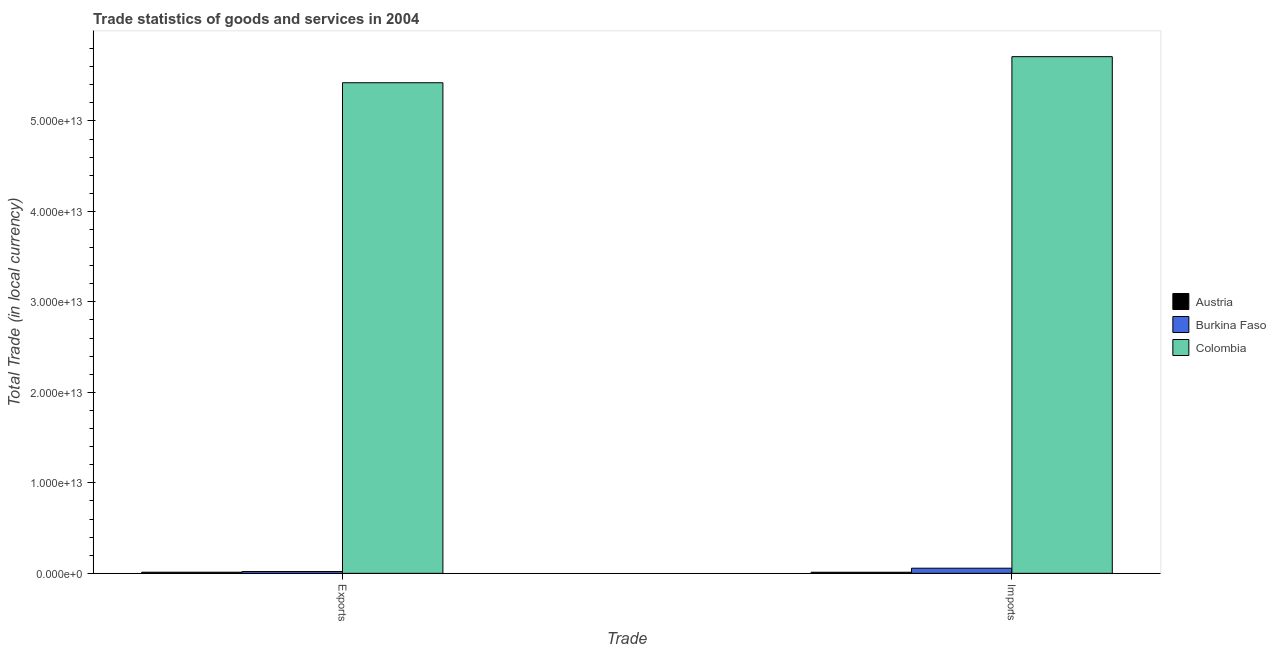How many bars are there on the 2nd tick from the left?
Offer a very short reply. 3. How many bars are there on the 2nd tick from the right?
Offer a terse response. 3. What is the label of the 2nd group of bars from the left?
Your answer should be compact. Imports. What is the export of goods and services in Austria?
Your answer should be compact. 1.24e+11. Across all countries, what is the maximum imports of goods and services?
Your response must be concise. 5.71e+13. Across all countries, what is the minimum imports of goods and services?
Keep it short and to the point. 1.20e+11. In which country was the export of goods and services maximum?
Offer a very short reply. Colombia. In which country was the imports of goods and services minimum?
Keep it short and to the point. Austria. What is the total export of goods and services in the graph?
Your answer should be compact. 5.45e+13. What is the difference between the export of goods and services in Burkina Faso and that in Austria?
Give a very brief answer. 7.61e+1. What is the difference between the export of goods and services in Burkina Faso and the imports of goods and services in Austria?
Offer a terse response. 7.99e+1. What is the average export of goods and services per country?
Provide a succinct answer. 1.82e+13. What is the difference between the export of goods and services and imports of goods and services in Colombia?
Keep it short and to the point. -2.88e+12. What is the ratio of the export of goods and services in Burkina Faso to that in Austria?
Offer a terse response. 1.62. Is the imports of goods and services in Austria less than that in Colombia?
Provide a succinct answer. Yes. In how many countries, is the imports of goods and services greater than the average imports of goods and services taken over all countries?
Your answer should be compact. 1. What does the 2nd bar from the left in Exports represents?
Make the answer very short. Burkina Faso. How many bars are there?
Provide a succinct answer. 6. What is the difference between two consecutive major ticks on the Y-axis?
Provide a succinct answer. 1.00e+13. Are the values on the major ticks of Y-axis written in scientific E-notation?
Provide a short and direct response. Yes. Does the graph contain grids?
Your answer should be compact. No. How are the legend labels stacked?
Your answer should be very brief. Vertical. What is the title of the graph?
Provide a succinct answer. Trade statistics of goods and services in 2004. Does "Fragile and conflict affected situations" appear as one of the legend labels in the graph?
Make the answer very short. No. What is the label or title of the X-axis?
Your answer should be very brief. Trade. What is the label or title of the Y-axis?
Offer a terse response. Total Trade (in local currency). What is the Total Trade (in local currency) in Austria in Exports?
Give a very brief answer. 1.24e+11. What is the Total Trade (in local currency) of Burkina Faso in Exports?
Make the answer very short. 2.00e+11. What is the Total Trade (in local currency) in Colombia in Exports?
Offer a very short reply. 5.42e+13. What is the Total Trade (in local currency) of Austria in Imports?
Keep it short and to the point. 1.20e+11. What is the Total Trade (in local currency) of Burkina Faso in Imports?
Offer a terse response. 5.67e+11. What is the Total Trade (in local currency) of Colombia in Imports?
Make the answer very short. 5.71e+13. Across all Trade, what is the maximum Total Trade (in local currency) in Austria?
Ensure brevity in your answer.  1.24e+11. Across all Trade, what is the maximum Total Trade (in local currency) of Burkina Faso?
Ensure brevity in your answer.  5.67e+11. Across all Trade, what is the maximum Total Trade (in local currency) in Colombia?
Give a very brief answer. 5.71e+13. Across all Trade, what is the minimum Total Trade (in local currency) of Austria?
Your answer should be compact. 1.20e+11. Across all Trade, what is the minimum Total Trade (in local currency) in Burkina Faso?
Keep it short and to the point. 2.00e+11. Across all Trade, what is the minimum Total Trade (in local currency) in Colombia?
Offer a very short reply. 5.42e+13. What is the total Total Trade (in local currency) in Austria in the graph?
Ensure brevity in your answer.  2.43e+11. What is the total Total Trade (in local currency) of Burkina Faso in the graph?
Provide a succinct answer. 7.66e+11. What is the total Total Trade (in local currency) in Colombia in the graph?
Make the answer very short. 1.11e+14. What is the difference between the Total Trade (in local currency) in Austria in Exports and that in Imports?
Your response must be concise. 3.74e+09. What is the difference between the Total Trade (in local currency) in Burkina Faso in Exports and that in Imports?
Provide a short and direct response. -3.67e+11. What is the difference between the Total Trade (in local currency) in Colombia in Exports and that in Imports?
Your response must be concise. -2.88e+12. What is the difference between the Total Trade (in local currency) in Austria in Exports and the Total Trade (in local currency) in Burkina Faso in Imports?
Ensure brevity in your answer.  -4.43e+11. What is the difference between the Total Trade (in local currency) in Austria in Exports and the Total Trade (in local currency) in Colombia in Imports?
Offer a very short reply. -5.70e+13. What is the difference between the Total Trade (in local currency) of Burkina Faso in Exports and the Total Trade (in local currency) of Colombia in Imports?
Provide a succinct answer. -5.69e+13. What is the average Total Trade (in local currency) of Austria per Trade?
Your answer should be compact. 1.22e+11. What is the average Total Trade (in local currency) in Burkina Faso per Trade?
Your answer should be compact. 3.83e+11. What is the average Total Trade (in local currency) of Colombia per Trade?
Make the answer very short. 5.57e+13. What is the difference between the Total Trade (in local currency) of Austria and Total Trade (in local currency) of Burkina Faso in Exports?
Provide a succinct answer. -7.61e+1. What is the difference between the Total Trade (in local currency) in Austria and Total Trade (in local currency) in Colombia in Exports?
Keep it short and to the point. -5.41e+13. What is the difference between the Total Trade (in local currency) in Burkina Faso and Total Trade (in local currency) in Colombia in Exports?
Offer a terse response. -5.40e+13. What is the difference between the Total Trade (in local currency) of Austria and Total Trade (in local currency) of Burkina Faso in Imports?
Give a very brief answer. -4.47e+11. What is the difference between the Total Trade (in local currency) in Austria and Total Trade (in local currency) in Colombia in Imports?
Offer a terse response. -5.70e+13. What is the difference between the Total Trade (in local currency) of Burkina Faso and Total Trade (in local currency) of Colombia in Imports?
Your answer should be compact. -5.65e+13. What is the ratio of the Total Trade (in local currency) in Austria in Exports to that in Imports?
Provide a short and direct response. 1.03. What is the ratio of the Total Trade (in local currency) of Burkina Faso in Exports to that in Imports?
Provide a succinct answer. 0.35. What is the ratio of the Total Trade (in local currency) of Colombia in Exports to that in Imports?
Provide a short and direct response. 0.95. What is the difference between the highest and the second highest Total Trade (in local currency) of Austria?
Offer a very short reply. 3.74e+09. What is the difference between the highest and the second highest Total Trade (in local currency) of Burkina Faso?
Offer a very short reply. 3.67e+11. What is the difference between the highest and the second highest Total Trade (in local currency) in Colombia?
Offer a terse response. 2.88e+12. What is the difference between the highest and the lowest Total Trade (in local currency) in Austria?
Keep it short and to the point. 3.74e+09. What is the difference between the highest and the lowest Total Trade (in local currency) in Burkina Faso?
Ensure brevity in your answer.  3.67e+11. What is the difference between the highest and the lowest Total Trade (in local currency) in Colombia?
Give a very brief answer. 2.88e+12. 